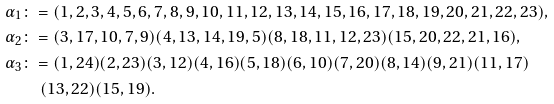<formula> <loc_0><loc_0><loc_500><loc_500>\alpha _ { 1 } & \colon = ( 1 , 2 , 3 , 4 , 5 , 6 , 7 , 8 , 9 , 1 0 , 1 1 , 1 2 , 1 3 , 1 4 , 1 5 , 1 6 , 1 7 , 1 8 , 1 9 , 2 0 , 2 1 , 2 2 , 2 3 ) , \\ \alpha _ { 2 } & \colon = ( 3 , 1 7 , 1 0 , 7 , 9 ) ( 4 , 1 3 , 1 4 , 1 9 , 5 ) ( 8 , 1 8 , 1 1 , 1 2 , 2 3 ) ( 1 5 , 2 0 , 2 2 , 2 1 , 1 6 ) , \\ \alpha _ { 3 } & \colon = ( 1 , 2 4 ) ( 2 , 2 3 ) ( 3 , 1 2 ) ( 4 , 1 6 ) ( 5 , 1 8 ) ( 6 , 1 0 ) ( 7 , 2 0 ) ( 8 , 1 4 ) ( 9 , 2 1 ) ( 1 1 , 1 7 ) \\ & \quad ( 1 3 , 2 2 ) ( 1 5 , 1 9 ) .</formula> 